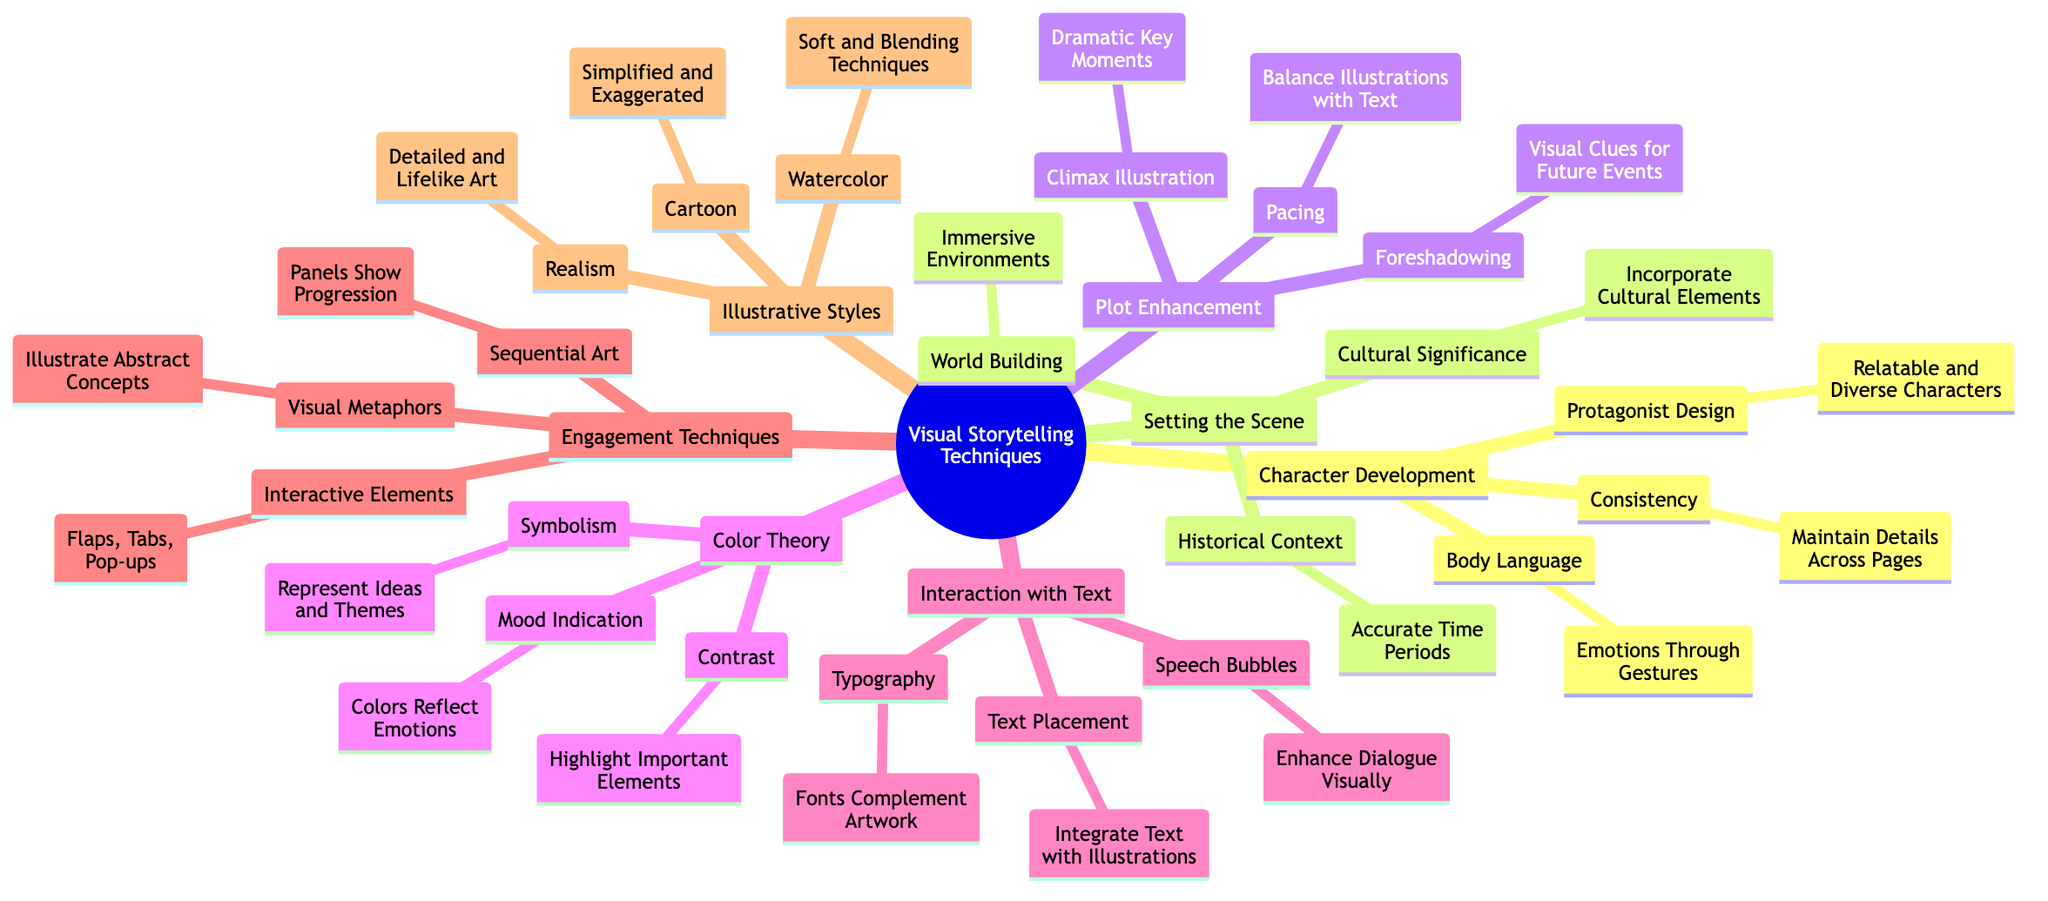What is the first main category under Visual Storytelling Techniques? The diagram shows "Character Development" as the first main category branching from the root node "Visual Storytelling Techniques."
Answer: Character Development How many main categories are present in the diagram? By reviewing the primary nodes that branch out from the root node, there are a total of seven main categories identified.
Answer: 7 What technique is used for expressing emotions through illustrations? The diagram indicates "Body Language" as the technique that helps in expressing emotions through gestures.
Answer: Body Language Which category discusses the use of color to represent ideas and themes? "Color Theory" includes a subcategory titled "Symbolism" that focuses on the use of color for representing ideas and themes.
Answer: Symbolism What is an example of an engagement technique listed in the diagram? The diagram identifies "Interactive Elements" such as flaps, tabs, and pop-ups as one of the engagement techniques used in visual storytelling.
Answer: Interactive Elements Which subcategory focuses on maintaining character details across pages? The diagram specifies "Consistency" under the "Character Development" category as focusing on maintaining character details across pages.
Answer: Consistency What is the relationship between "Foreshadowing" and "Plot Enhancement"? "Foreshadowing" is a subcategory of "Plot Enhancement," indicating that foreshadowing is used to enhance the plot through visual clues.
Answer: Subcategory relationship How does "Pacing" contribute to storytelling in children's books? "Pacing" is highlighted under "Plot Enhancement" as a means of balancing illustrations with text, facilitating the flow of the story.
Answer: Balancing illustrations with text What illustrative style is described as having detailed and lifelike art? The diagram identifies "Realism" as the illustrative style characterized by detailed and lifelike art.
Answer: Realism Which technique enhances dialogue visually in children's books? The diagram points out "Speech Bubbles" as a technique that enhances dialogue through visuals.
Answer: Speech Bubbles 